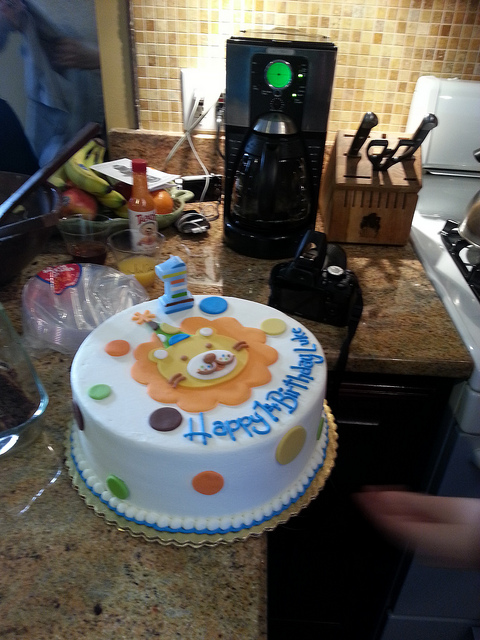Read and extract the text from this image. Happy Birthday 